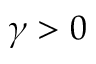<formula> <loc_0><loc_0><loc_500><loc_500>\gamma > 0</formula> 